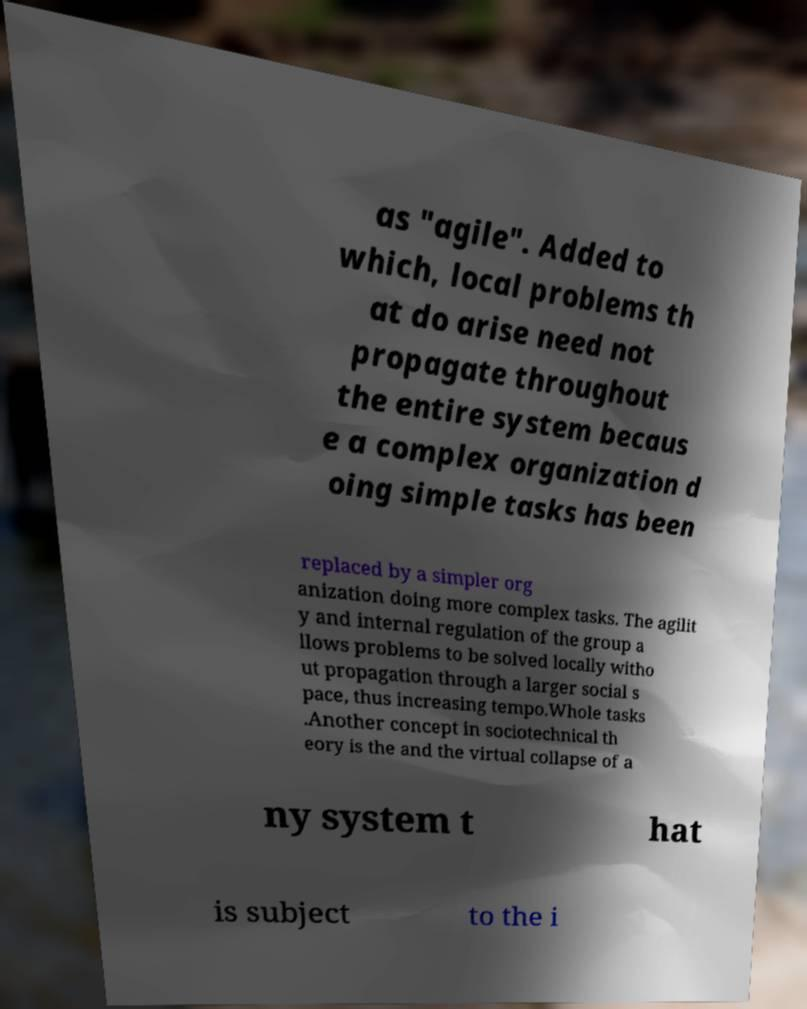Can you read and provide the text displayed in the image?This photo seems to have some interesting text. Can you extract and type it out for me? as "agile". Added to which, local problems th at do arise need not propagate throughout the entire system becaus e a complex organization d oing simple tasks has been replaced by a simpler org anization doing more complex tasks. The agilit y and internal regulation of the group a llows problems to be solved locally witho ut propagation through a larger social s pace, thus increasing tempo.Whole tasks .Another concept in sociotechnical th eory is the and the virtual collapse of a ny system t hat is subject to the i 